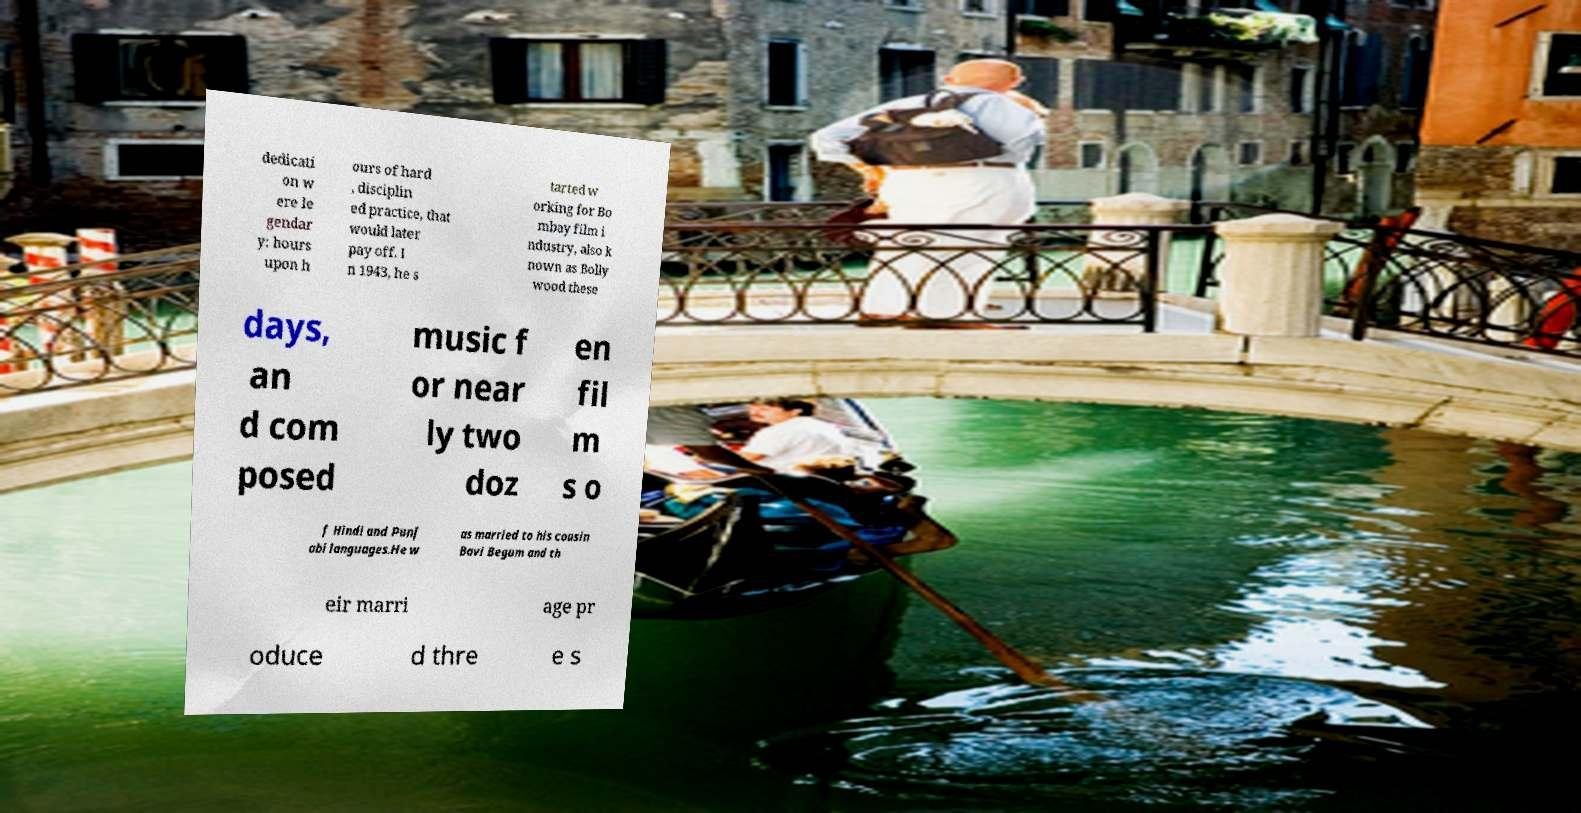Please read and relay the text visible in this image. What does it say? dedicati on w ere le gendar y: hours upon h ours of hard , disciplin ed practice, that would later pay off. I n 1943, he s tarted w orking for Bo mbay film i ndustry, also k nown as Bolly wood these days, an d com posed music f or near ly two doz en fil m s o f Hindi and Punj abi languages.He w as married to his cousin Bavi Begum and th eir marri age pr oduce d thre e s 